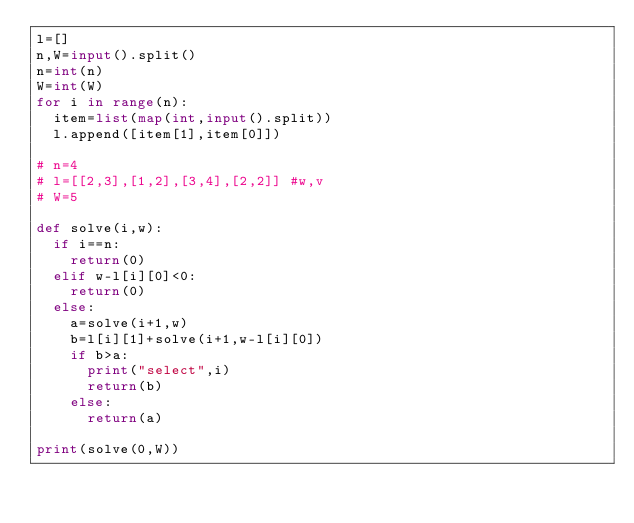<code> <loc_0><loc_0><loc_500><loc_500><_Python_>l=[]
n,W=input().split()
n=int(n)
W=int(W)
for i in range(n):
	item=list(map(int,input().split))
	l.append([item[1],item[0]])

# n=4
# l=[[2,3],[1,2],[3,4],[2,2]] #w,v
# W=5

def solve(i,w):
	if i==n:
		return(0)
	elif w-l[i][0]<0:
		return(0)
	else:
		a=solve(i+1,w)
		b=l[i][1]+solve(i+1,w-l[i][0])
		if b>a:
			print("select",i)
			return(b)
		else:
			return(a)

print(solve(0,W))</code> 